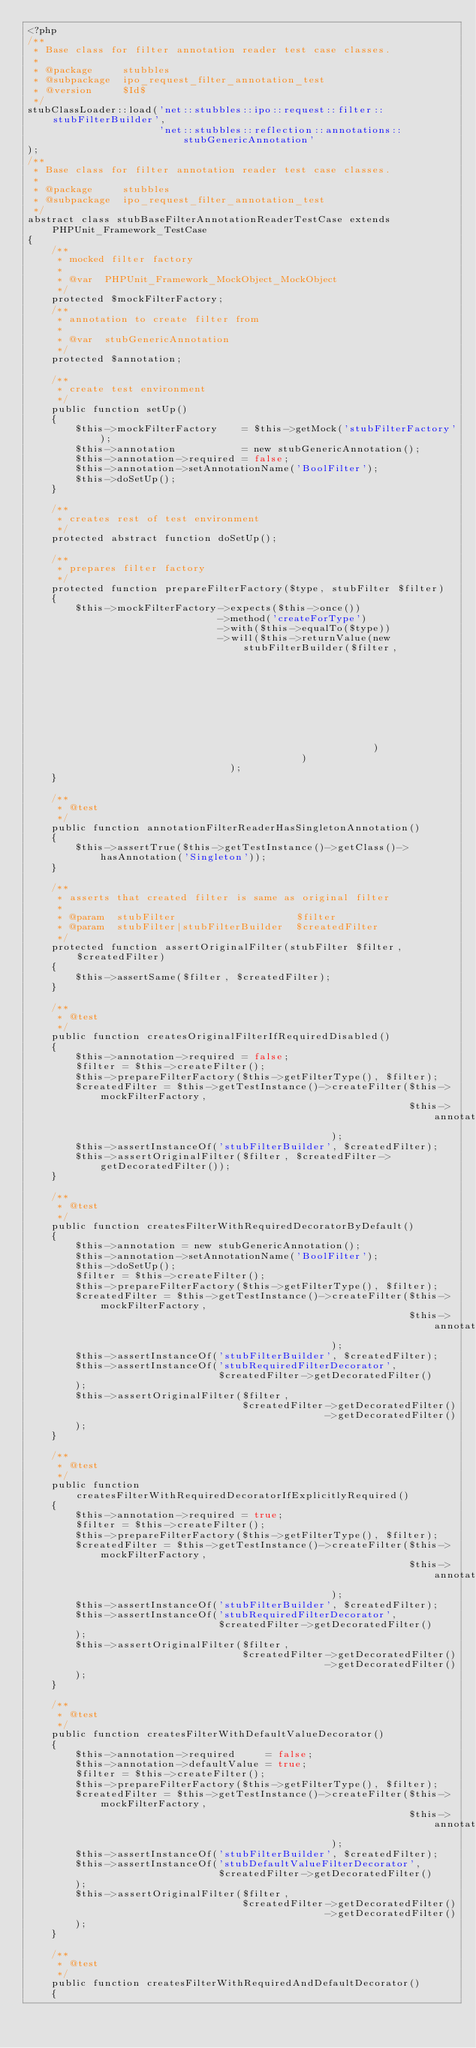Convert code to text. <code><loc_0><loc_0><loc_500><loc_500><_PHP_><?php
/**
 * Base class for filter annotation reader test case classes.
 *
 * @package     stubbles
 * @subpackage  ipo_request_filter_annotation_test
 * @version     $Id$
 */
stubClassLoader::load('net::stubbles::ipo::request::filter::stubFilterBuilder',
                      'net::stubbles::reflection::annotations::stubGenericAnnotation'
);
/**
 * Base class for filter annotation reader test case classes.
 *
 * @package     stubbles
 * @subpackage  ipo_request_filter_annotation_test
 */
abstract class stubBaseFilterAnnotationReaderTestCase extends PHPUnit_Framework_TestCase
{
    /**
     * mocked filter factory
     *
     * @var  PHPUnit_Framework_MockObject_MockObject
     */
    protected $mockFilterFactory;
    /**
     * annotation to create filter from
     *
     * @var  stubGenericAnnotation
     */
    protected $annotation;

    /**
     * create test environment
     */
    public function setUp()
    {
        $this->mockFilterFactory    = $this->getMock('stubFilterFactory');
        $this->annotation           = new stubGenericAnnotation();
        $this->annotation->required = false;
        $this->annotation->setAnnotationName('BoolFilter');
        $this->doSetUp();
    }

    /**
     * creates rest of test environment
     */
    protected abstract function doSetUp();

    /**
     * prepares filter factory
     */
    protected function prepareFilterFactory($type, stubFilter $filter)
    {
        $this->mockFilterFactory->expects($this->once())
                                ->method('createForType')
                                ->with($this->equalTo($type))
                                ->will($this->returnValue(new stubFilterBuilder($filter,
                                                                                $this->getMock('stubRequestValueErrorFactory')
                                                          )
                                              )
                                  );
    }

    /**
     * @test
     */
    public function annotationFilterReaderHasSingletonAnnotation()
    {
        $this->assertTrue($this->getTestInstance()->getClass()->hasAnnotation('Singleton'));
    }

    /**
     * asserts that created filter is same as original filter
     *
     * @param  stubFilter                    $filter
     * @param  stubFilter|stubFilterBuilder  $createdFilter
     */
    protected function assertOriginalFilter(stubFilter $filter, $createdFilter)
    {
        $this->assertSame($filter, $createdFilter);
    }

    /**
     * @test
     */
    public function createsOriginalFilterIfRequiredDisabled()
    {
        $this->annotation->required = false;
        $filter = $this->createFilter();
        $this->prepareFilterFactory($this->getFilterType(), $filter);
        $createdFilter = $this->getTestInstance()->createFilter($this->mockFilterFactory,
                                                                $this->annotation
                                                   );
        $this->assertInstanceOf('stubFilterBuilder', $createdFilter);
        $this->assertOriginalFilter($filter, $createdFilter->getDecoratedFilter());
    }

    /**
     * @test
     */
    public function createsFilterWithRequiredDecoratorByDefault()
    {
        $this->annotation = new stubGenericAnnotation();
        $this->annotation->setAnnotationName('BoolFilter');
        $this->doSetUp();
        $filter = $this->createFilter();
        $this->prepareFilterFactory($this->getFilterType(), $filter);
        $createdFilter = $this->getTestInstance()->createFilter($this->mockFilterFactory,
                                                                $this->annotation
                                                   );
        $this->assertInstanceOf('stubFilterBuilder', $createdFilter);
        $this->assertInstanceOf('stubRequiredFilterDecorator',
                                $createdFilter->getDecoratedFilter()
        );
        $this->assertOriginalFilter($filter,
                                    $createdFilter->getDecoratedFilter()
                                                  ->getDecoratedFilter()
        );
    }

    /**
     * @test
     */
    public function createsFilterWithRequiredDecoratorIfExplicitlyRequired()
    {
        $this->annotation->required = true;
        $filter = $this->createFilter();
        $this->prepareFilterFactory($this->getFilterType(), $filter);
        $createdFilter = $this->getTestInstance()->createFilter($this->mockFilterFactory,
                                                                $this->annotation
                                                   );
        $this->assertInstanceOf('stubFilterBuilder', $createdFilter);
        $this->assertInstanceOf('stubRequiredFilterDecorator',
                                $createdFilter->getDecoratedFilter()
        );
        $this->assertOriginalFilter($filter,
                                    $createdFilter->getDecoratedFilter()
                                                  ->getDecoratedFilter()
        );
    }

    /**
     * @test
     */
    public function createsFilterWithDefaultValueDecorator()
    {
        $this->annotation->required     = false;
        $this->annotation->defaultValue = true;
        $filter = $this->createFilter();
        $this->prepareFilterFactory($this->getFilterType(), $filter);
        $createdFilter = $this->getTestInstance()->createFilter($this->mockFilterFactory,
                                                                $this->annotation
                                                   );
        $this->assertInstanceOf('stubFilterBuilder', $createdFilter);
        $this->assertInstanceOf('stubDefaultValueFilterDecorator',
                                $createdFilter->getDecoratedFilter()
        );
        $this->assertOriginalFilter($filter,
                                    $createdFilter->getDecoratedFilter()
                                                  ->getDecoratedFilter()
        );
    }

    /**
     * @test
     */
    public function createsFilterWithRequiredAndDefaultDecorator()
    {</code> 